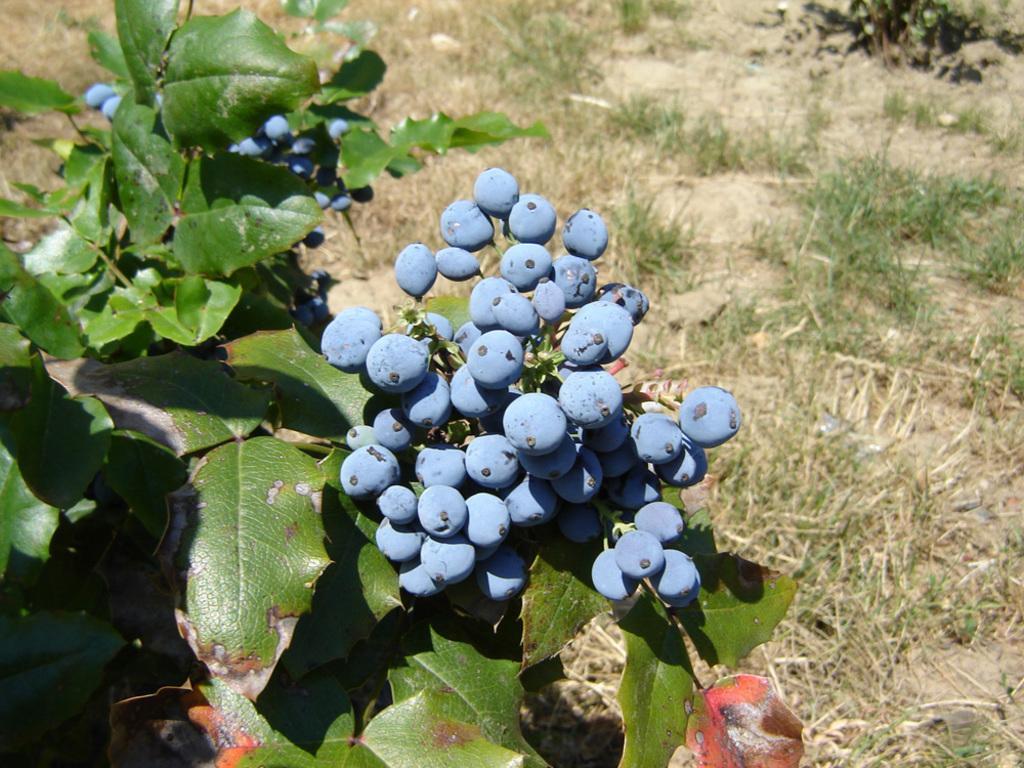Can you describe this image briefly? In the picture I can see plants. These plants has blue colored berries. In the background I can see the grass. 